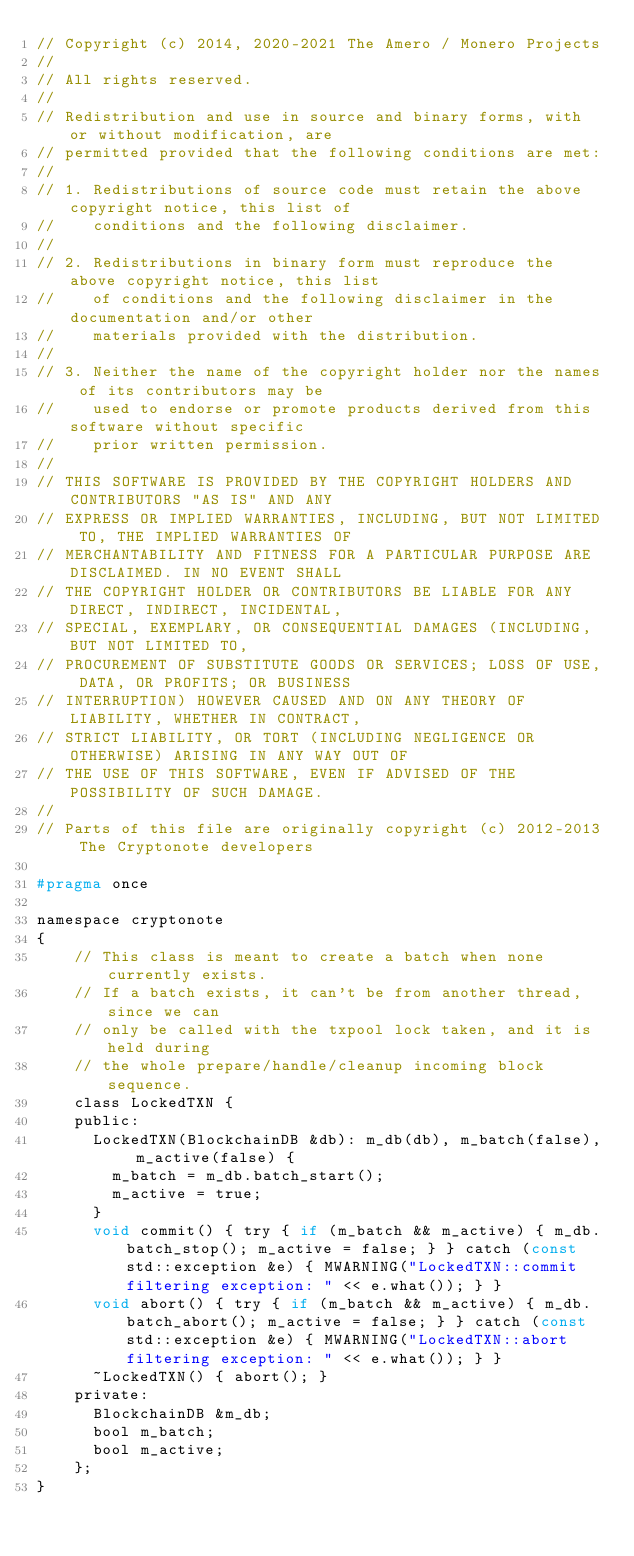<code> <loc_0><loc_0><loc_500><loc_500><_C_>// Copyright (c) 2014, 2020-2021 The Amero / Monero Projects
//
// All rights reserved.
//
// Redistribution and use in source and binary forms, with or without modification, are
// permitted provided that the following conditions are met:
//
// 1. Redistributions of source code must retain the above copyright notice, this list of
//    conditions and the following disclaimer.
//
// 2. Redistributions in binary form must reproduce the above copyright notice, this list
//    of conditions and the following disclaimer in the documentation and/or other
//    materials provided with the distribution.
//
// 3. Neither the name of the copyright holder nor the names of its contributors may be
//    used to endorse or promote products derived from this software without specific
//    prior written permission.
//
// THIS SOFTWARE IS PROVIDED BY THE COPYRIGHT HOLDERS AND CONTRIBUTORS "AS IS" AND ANY
// EXPRESS OR IMPLIED WARRANTIES, INCLUDING, BUT NOT LIMITED TO, THE IMPLIED WARRANTIES OF
// MERCHANTABILITY AND FITNESS FOR A PARTICULAR PURPOSE ARE DISCLAIMED. IN NO EVENT SHALL
// THE COPYRIGHT HOLDER OR CONTRIBUTORS BE LIABLE FOR ANY DIRECT, INDIRECT, INCIDENTAL,
// SPECIAL, EXEMPLARY, OR CONSEQUENTIAL DAMAGES (INCLUDING, BUT NOT LIMITED TO,
// PROCUREMENT OF SUBSTITUTE GOODS OR SERVICES; LOSS OF USE, DATA, OR PROFITS; OR BUSINESS
// INTERRUPTION) HOWEVER CAUSED AND ON ANY THEORY OF LIABILITY, WHETHER IN CONTRACT,
// STRICT LIABILITY, OR TORT (INCLUDING NEGLIGENCE OR OTHERWISE) ARISING IN ANY WAY OUT OF
// THE USE OF THIS SOFTWARE, EVEN IF ADVISED OF THE POSSIBILITY OF SUCH DAMAGE.
//
// Parts of this file are originally copyright (c) 2012-2013 The Cryptonote developers

#pragma once

namespace cryptonote
{
    // This class is meant to create a batch when none currently exists.
    // If a batch exists, it can't be from another thread, since we can
    // only be called with the txpool lock taken, and it is held during
    // the whole prepare/handle/cleanup incoming block sequence.
    class LockedTXN {
    public:
      LockedTXN(BlockchainDB &db): m_db(db), m_batch(false), m_active(false) {
        m_batch = m_db.batch_start();
        m_active = true;
      }
      void commit() { try { if (m_batch && m_active) { m_db.batch_stop(); m_active = false; } } catch (const std::exception &e) { MWARNING("LockedTXN::commit filtering exception: " << e.what()); } }
      void abort() { try { if (m_batch && m_active) { m_db.batch_abort(); m_active = false; } } catch (const std::exception &e) { MWARNING("LockedTXN::abort filtering exception: " << e.what()); } }
      ~LockedTXN() { abort(); }
    private:
      BlockchainDB &m_db;
      bool m_batch;
      bool m_active;
    };
}
</code> 